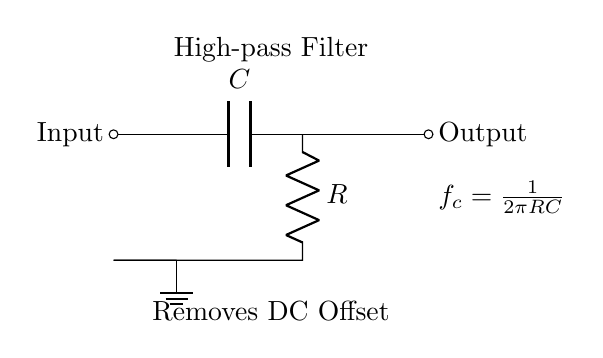What components are present in this high-pass filter circuit? The circuit diagram displays two main components: a capacitor and a resistor. These two are essential for forming a high-pass filter configuration.
Answer: Capacitor and Resistor What is the purpose of the capacitor in this circuit? The capacitor in a high-pass filter allows AC signals to pass while blocking DC signals. This characteristic is crucial for removing DC offset from audio signals.
Answer: Remove DC offset What is the output of this circuit labeled as? The output terminal of the circuit is labeled as "Output," indicating where the filtered audio signal can be taken.
Answer: Output How is the cutoff frequency calculated in this filter? The cutoff frequency 'fc' is defined by the formula fc = 1/(2πRC), where R is the resistance and C is the capacitance in the circuit. This formula shows the relationship between the cutoff frequency and the circuit components.
Answer: fc = 1/(2πRC) What does the label "Removes DC Offset" signify in the circuit? This label indicates that the purpose of the high-pass filter is to eliminate any DC offset present in the audio signal, allowing only the AC component to pass through.
Answer: Eliminates DC offset What effect does increasing the resistance R have on the cutoff frequency fc? Increasing the resistance R will decrease the cutoff frequency fc, as they are inversely related in the formula fc = 1/(2πRC). This means that the filter will allow lower frequencies to pass through when resistance is increased.
Answer: Decreases fc 